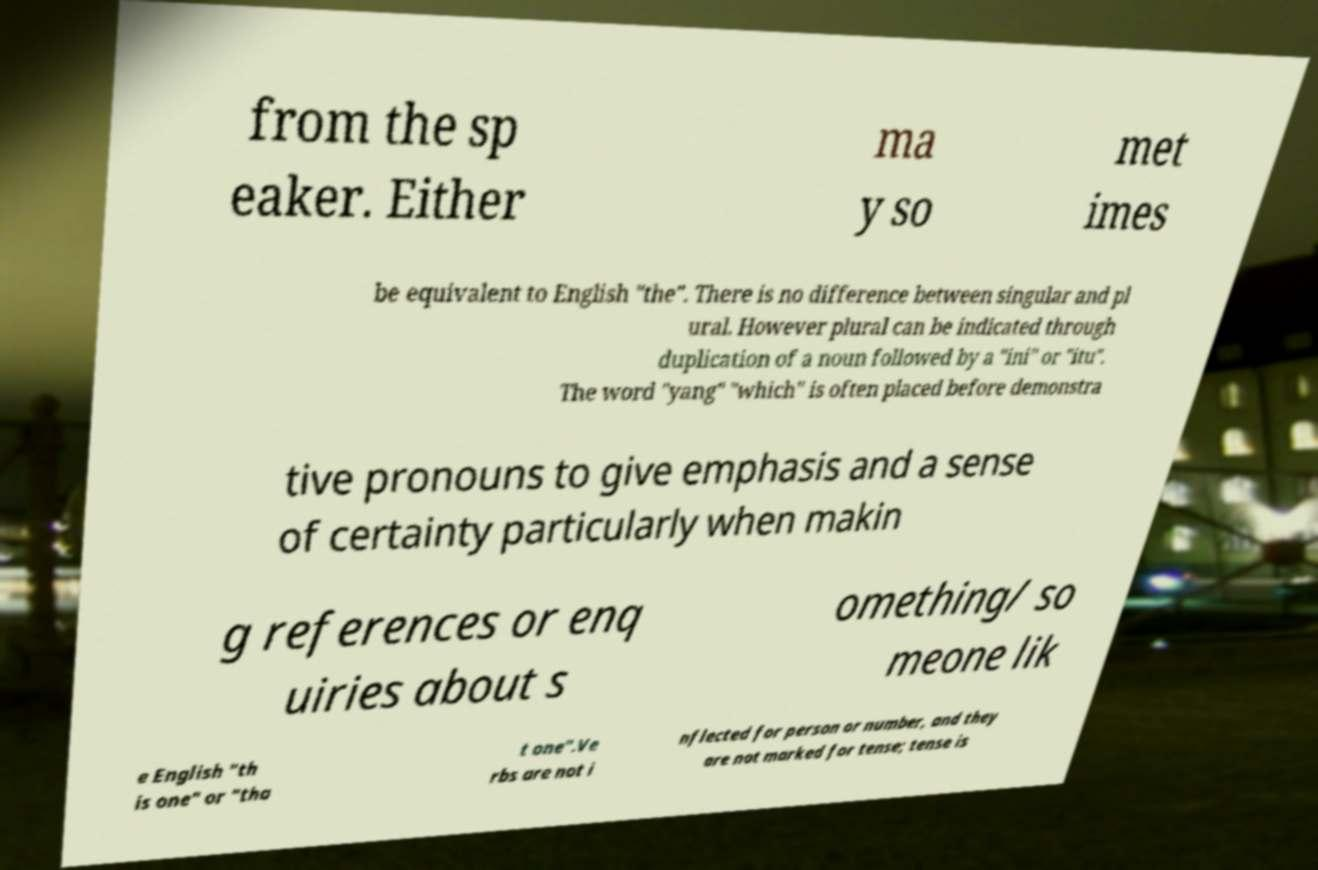Can you read and provide the text displayed in the image?This photo seems to have some interesting text. Can you extract and type it out for me? from the sp eaker. Either ma y so met imes be equivalent to English "the". There is no difference between singular and pl ural. However plural can be indicated through duplication of a noun followed by a "ini" or "itu". The word "yang" "which" is often placed before demonstra tive pronouns to give emphasis and a sense of certainty particularly when makin g references or enq uiries about s omething/ so meone lik e English "th is one" or "tha t one".Ve rbs are not i nflected for person or number, and they are not marked for tense; tense is 